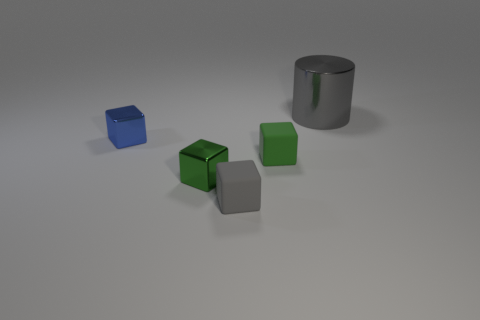Is there anything else that is the same size as the metal cylinder?
Offer a terse response. No. What number of big objects are green cylinders or metallic objects?
Your answer should be very brief. 1. Is there another tiny metal thing of the same shape as the blue shiny object?
Your answer should be compact. Yes. Is the tiny gray object the same shape as the blue object?
Your response must be concise. Yes. There is a block that is in front of the metallic block that is right of the small blue block; what color is it?
Your answer should be very brief. Gray. What color is the other shiny cube that is the same size as the green shiny cube?
Your answer should be very brief. Blue. What number of matte things are cylinders or small blue objects?
Offer a very short reply. 0. There is a gray object that is behind the small green metal object; how many blue shiny objects are to the left of it?
Ensure brevity in your answer.  1. What is the size of the rubber block that is the same color as the big cylinder?
Your answer should be compact. Small. How many things are either small matte balls or gray objects that are on the left side of the metal cylinder?
Provide a short and direct response. 1. 